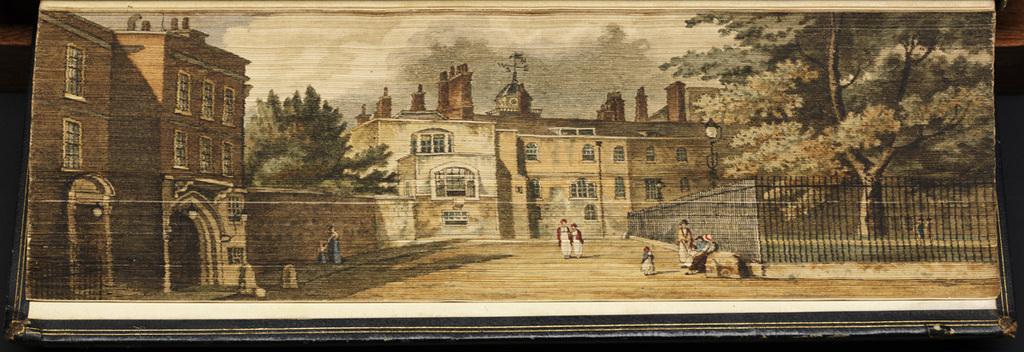Please provide a concise description of this image. This is an edited image. In the center we can see the group of persons. On the right we can see the metal rods. In the background there is a sky, trees and we can see the buildings. 